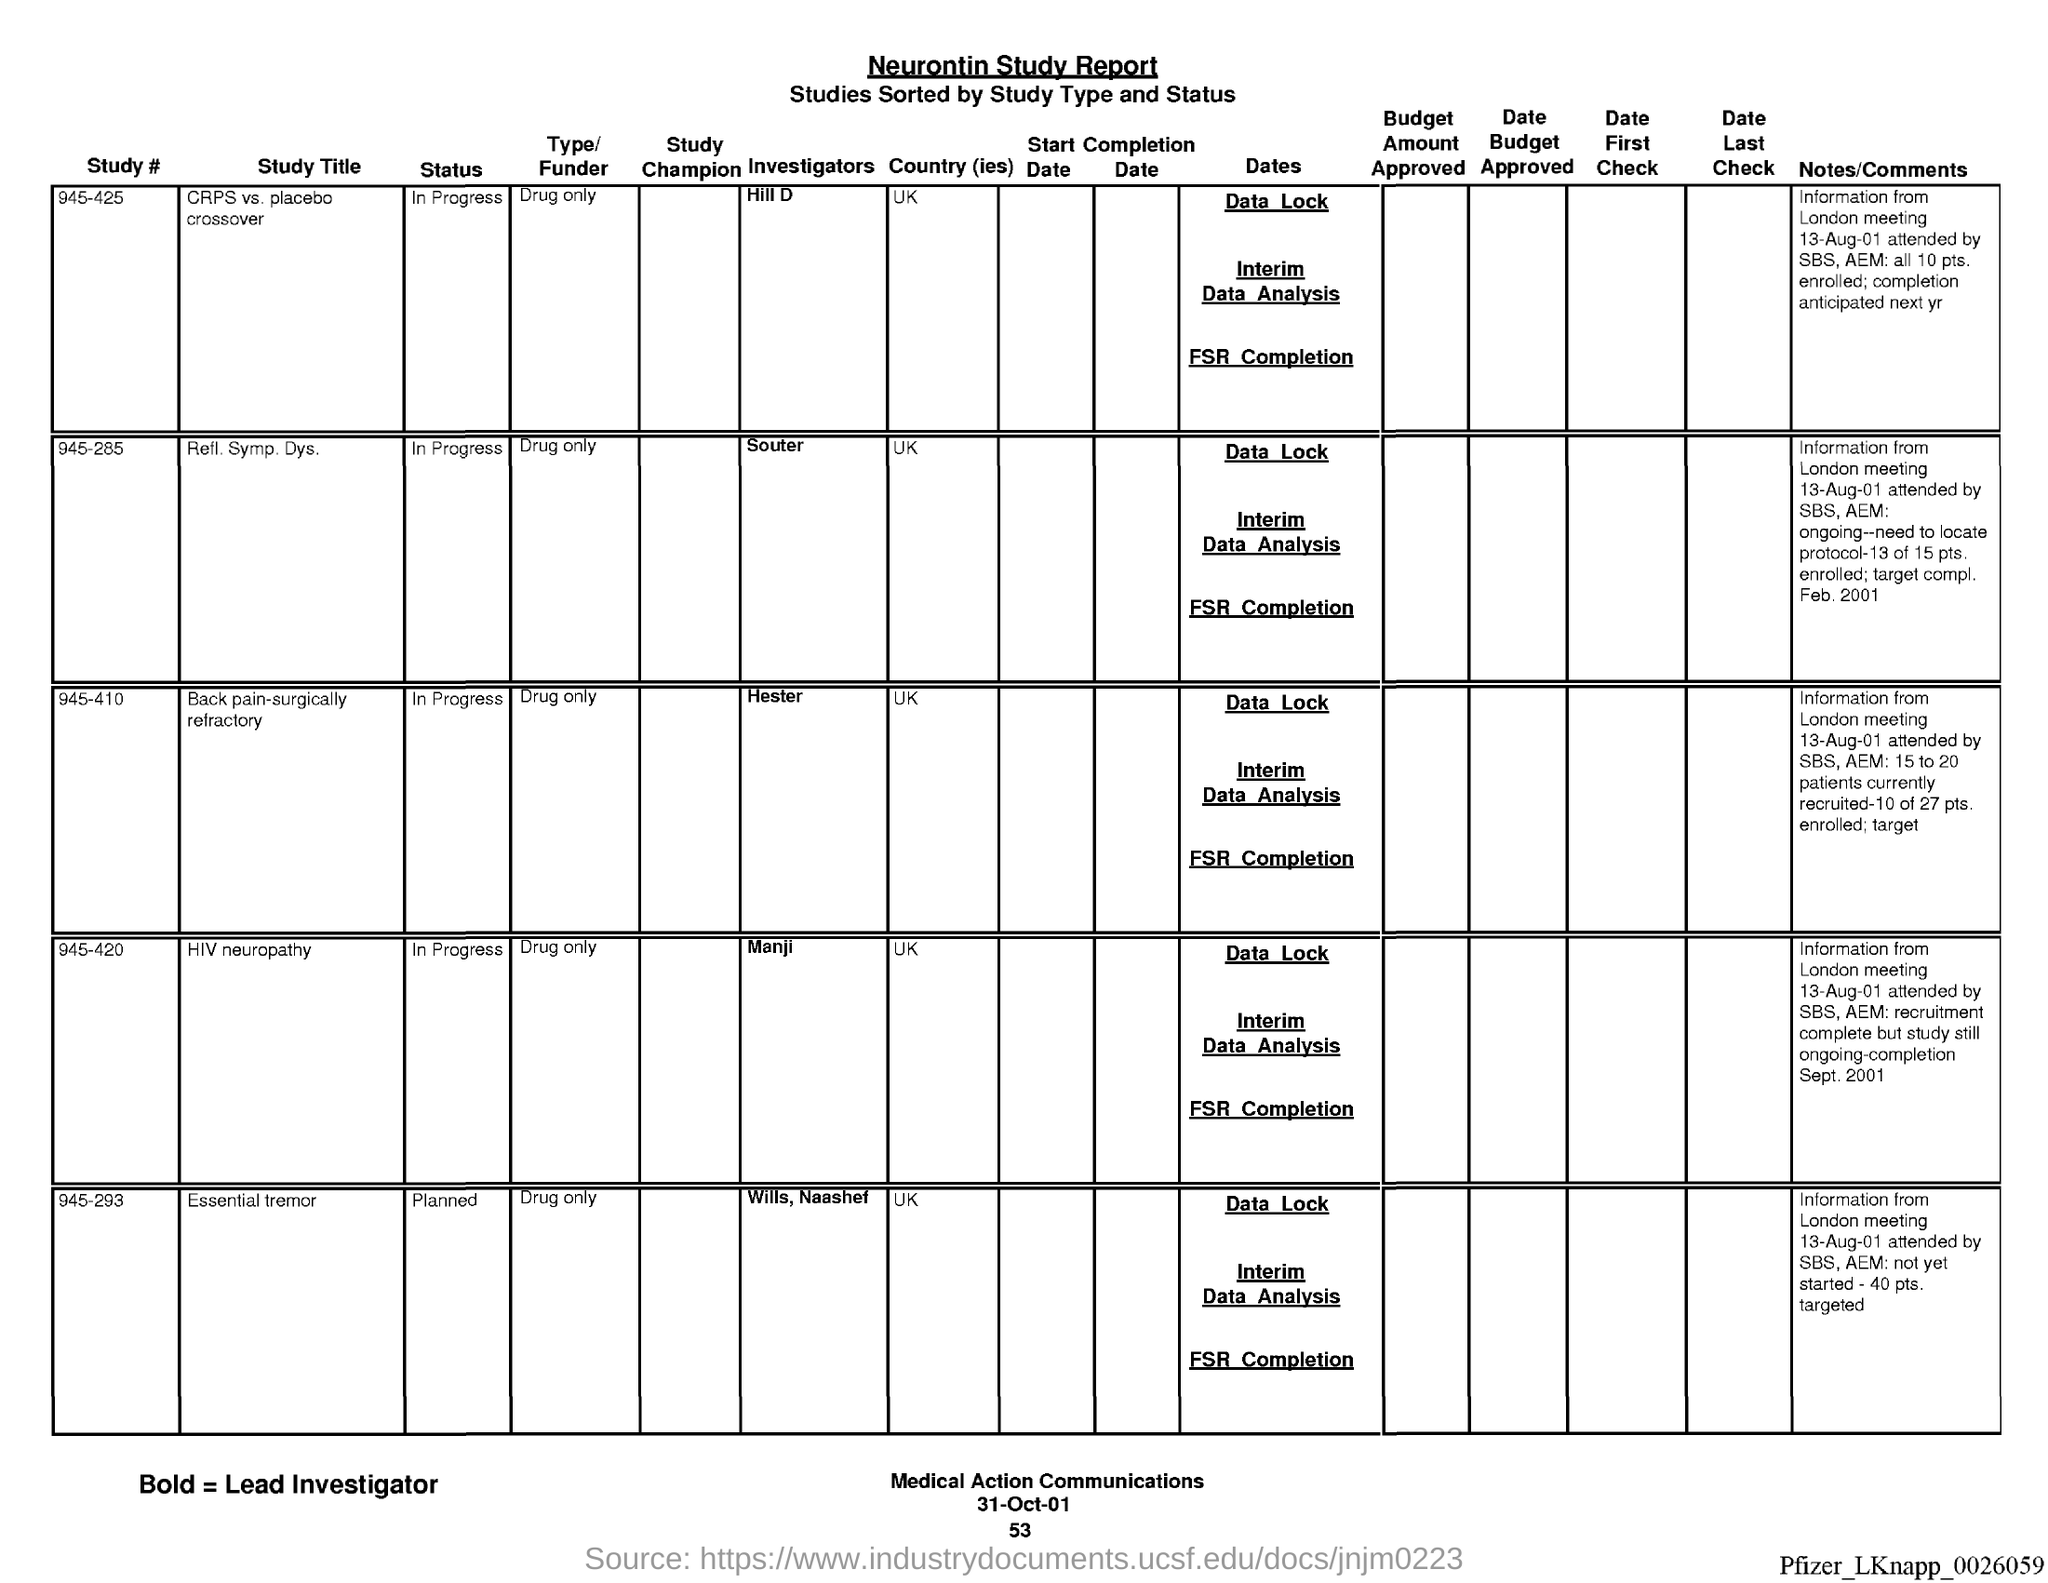Mention a couple of crucial points in this snapshot. The name of the report is the Neurontin Study Report. I request information on the page number that is below the date 53. 